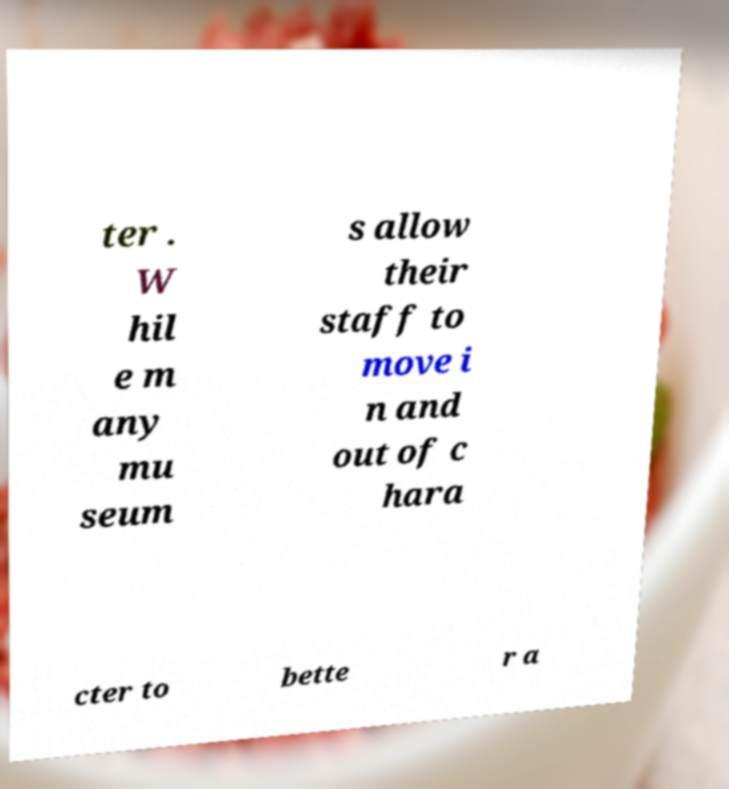Can you accurately transcribe the text from the provided image for me? ter . W hil e m any mu seum s allow their staff to move i n and out of c hara cter to bette r a 